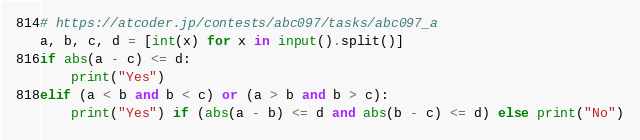Convert code to text. <code><loc_0><loc_0><loc_500><loc_500><_Python_># https://atcoder.jp/contests/abc097/tasks/abc097_a
a, b, c, d = [int(x) for x in input().split()]
if abs(a - c) <= d:
    print("Yes")
elif (a < b and b < c) or (a > b and b > c):
    print("Yes") if (abs(a - b) <= d and abs(b - c) <= d) else print("No")
</code> 